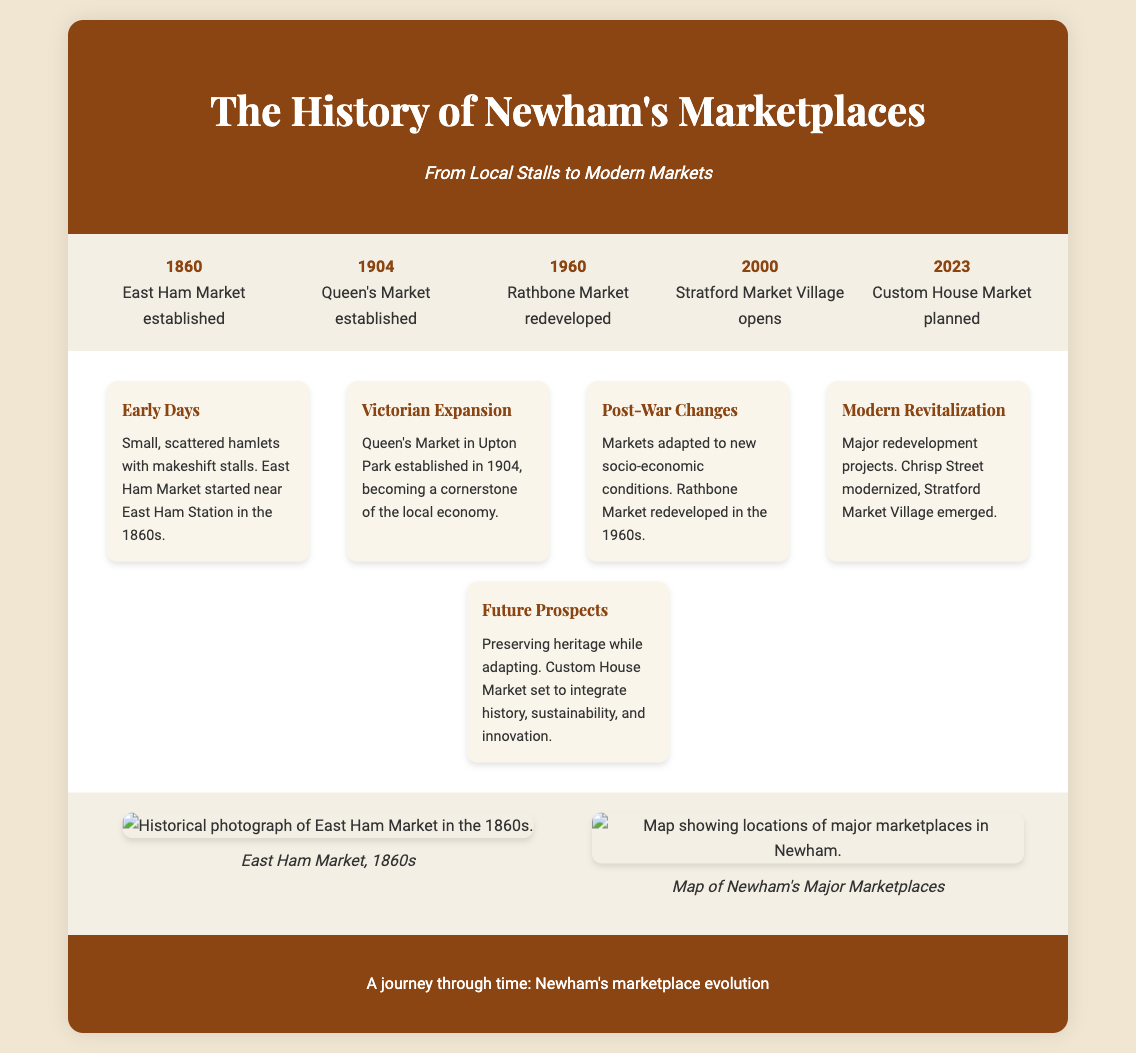what year was East Ham Market established? The document states that East Ham Market was established in the year 1860.
Answer: 1860 which market was established in 1904? The timeline indicates that Queen's Market was established in 1904.
Answer: Queen's Market what major redevelopment occurred in the 1960s? The document notes that Rathbone Market was redeveloped during the 1960s.
Answer: Rathbone Market what is one aspect of Custom House Market planned for 2023? According to the document, Custom House Market is set to integrate history, sustainability, and innovation.
Answer: Integrate history, sustainability, and innovation what significant change occurred after World War II? The document mentions that markets adapted to new socio-economic conditions after the war, specifically referring to the redevelopment of Rathbone Market.
Answer: Markets adapted to new socio-economic conditions what image is included for East Ham Market? The visuals show a historical photograph of East Ham Market in the 1860s.
Answer: Historical photograph of East Ham Market in the 1860s how many major markets are highlighted in the timeline? The timeline includes five notable markets established or redeveloped over the years.
Answer: Five what does the subtitle of the infographic convey? The subtitle reflects the journey from local stalls to modern markets, emphasizing change over time in Newham's marketplaces.
Answer: From Local Stalls to Modern Markets 